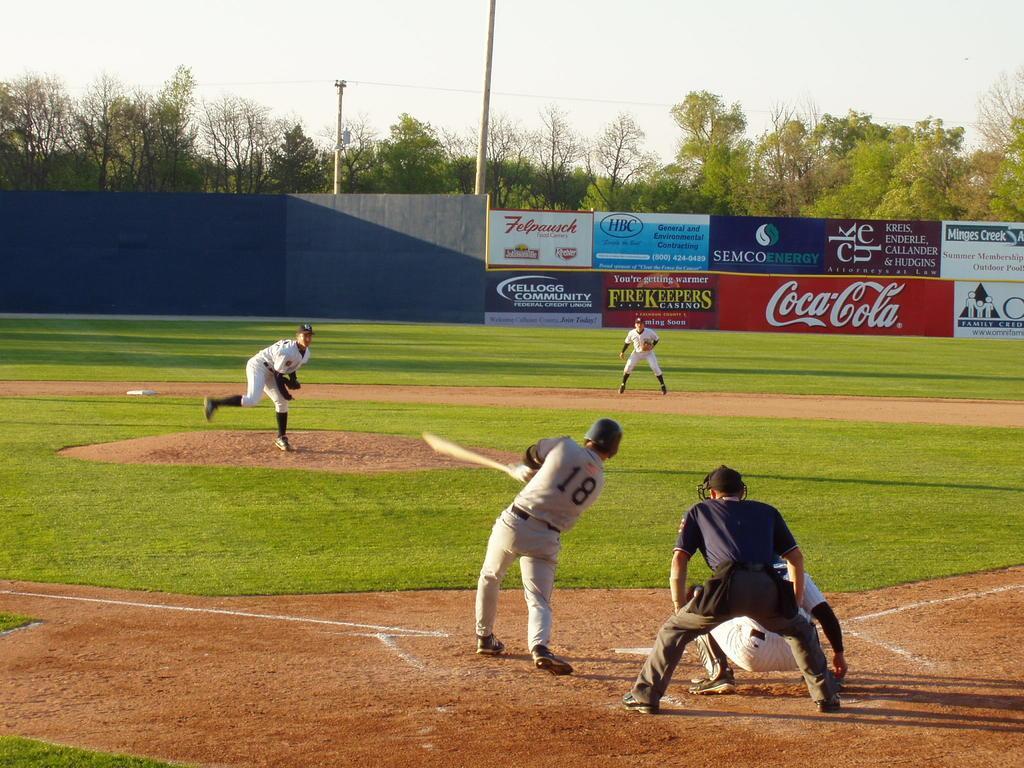In one or two sentences, can you explain what this image depicts? In the picture we can see a playground with a grass surface on it we can see some people are playing a baseball and they are wearing a sports wear and in the background we can see a wall with some advertisements and behind it we can see trees, poles and sky. 